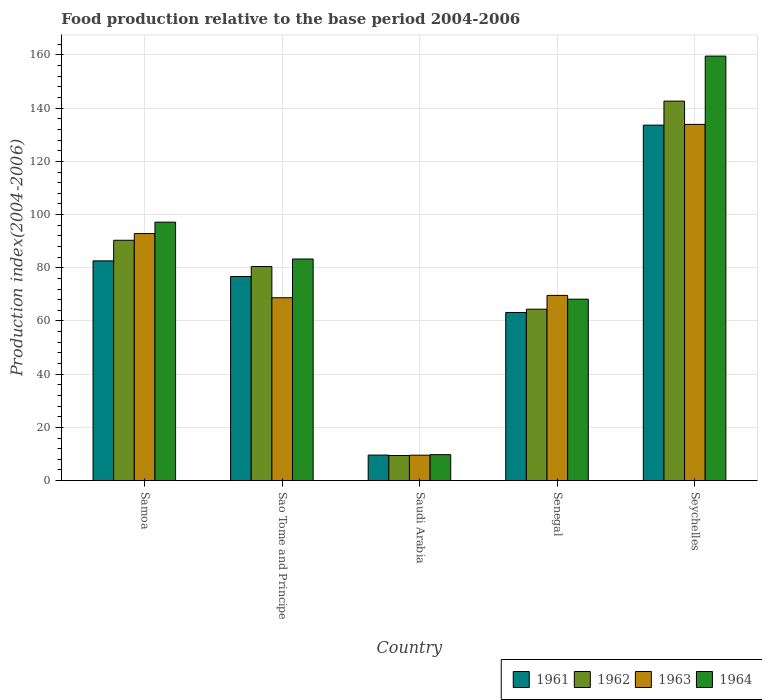How many different coloured bars are there?
Your answer should be very brief. 4. How many groups of bars are there?
Your answer should be compact. 5. How many bars are there on the 2nd tick from the left?
Offer a terse response. 4. How many bars are there on the 5th tick from the right?
Provide a short and direct response. 4. What is the label of the 4th group of bars from the left?
Your answer should be compact. Senegal. In how many cases, is the number of bars for a given country not equal to the number of legend labels?
Keep it short and to the point. 0. What is the food production index in 1964 in Samoa?
Your response must be concise. 97.15. Across all countries, what is the maximum food production index in 1962?
Your answer should be very brief. 142.65. Across all countries, what is the minimum food production index in 1962?
Provide a succinct answer. 9.42. In which country was the food production index in 1961 maximum?
Keep it short and to the point. Seychelles. In which country was the food production index in 1961 minimum?
Ensure brevity in your answer.  Saudi Arabia. What is the total food production index in 1964 in the graph?
Your answer should be very brief. 417.95. What is the difference between the food production index in 1964 in Samoa and that in Seychelles?
Ensure brevity in your answer.  -62.42. What is the difference between the food production index in 1962 in Sao Tome and Principe and the food production index in 1964 in Saudi Arabia?
Ensure brevity in your answer.  70.71. What is the average food production index in 1963 per country?
Ensure brevity in your answer.  74.93. What is the difference between the food production index of/in 1963 and food production index of/in 1964 in Samoa?
Provide a succinct answer. -4.29. What is the ratio of the food production index in 1961 in Samoa to that in Seychelles?
Make the answer very short. 0.62. Is the food production index in 1963 in Sao Tome and Principe less than that in Saudi Arabia?
Provide a short and direct response. No. What is the difference between the highest and the second highest food production index in 1961?
Ensure brevity in your answer.  5.88. What is the difference between the highest and the lowest food production index in 1961?
Keep it short and to the point. 124.04. Is the sum of the food production index in 1961 in Senegal and Seychelles greater than the maximum food production index in 1963 across all countries?
Give a very brief answer. Yes. What does the 3rd bar from the left in Seychelles represents?
Provide a short and direct response. 1963. How many bars are there?
Your answer should be very brief. 20. How many countries are there in the graph?
Provide a short and direct response. 5. What is the difference between two consecutive major ticks on the Y-axis?
Give a very brief answer. 20. Does the graph contain any zero values?
Ensure brevity in your answer.  No. Does the graph contain grids?
Make the answer very short. Yes. Where does the legend appear in the graph?
Give a very brief answer. Bottom right. What is the title of the graph?
Provide a succinct answer. Food production relative to the base period 2004-2006. Does "2014" appear as one of the legend labels in the graph?
Your response must be concise. No. What is the label or title of the X-axis?
Offer a terse response. Country. What is the label or title of the Y-axis?
Ensure brevity in your answer.  Production index(2004-2006). What is the Production index(2004-2006) in 1961 in Samoa?
Provide a short and direct response. 82.6. What is the Production index(2004-2006) in 1962 in Samoa?
Offer a very short reply. 90.34. What is the Production index(2004-2006) in 1963 in Samoa?
Provide a succinct answer. 92.86. What is the Production index(2004-2006) in 1964 in Samoa?
Your answer should be very brief. 97.15. What is the Production index(2004-2006) of 1961 in Sao Tome and Principe?
Give a very brief answer. 76.72. What is the Production index(2004-2006) of 1962 in Sao Tome and Principe?
Keep it short and to the point. 80.46. What is the Production index(2004-2006) in 1963 in Sao Tome and Principe?
Keep it short and to the point. 68.73. What is the Production index(2004-2006) of 1964 in Sao Tome and Principe?
Provide a succinct answer. 83.29. What is the Production index(2004-2006) of 1961 in Saudi Arabia?
Offer a very short reply. 9.58. What is the Production index(2004-2006) of 1962 in Saudi Arabia?
Give a very brief answer. 9.42. What is the Production index(2004-2006) of 1963 in Saudi Arabia?
Offer a terse response. 9.54. What is the Production index(2004-2006) in 1964 in Saudi Arabia?
Your answer should be compact. 9.75. What is the Production index(2004-2006) in 1961 in Senegal?
Ensure brevity in your answer.  63.19. What is the Production index(2004-2006) of 1962 in Senegal?
Your answer should be compact. 64.43. What is the Production index(2004-2006) in 1963 in Senegal?
Ensure brevity in your answer.  69.61. What is the Production index(2004-2006) in 1964 in Senegal?
Offer a very short reply. 68.19. What is the Production index(2004-2006) of 1961 in Seychelles?
Your answer should be very brief. 133.62. What is the Production index(2004-2006) of 1962 in Seychelles?
Offer a terse response. 142.65. What is the Production index(2004-2006) in 1963 in Seychelles?
Ensure brevity in your answer.  133.9. What is the Production index(2004-2006) of 1964 in Seychelles?
Your answer should be compact. 159.57. Across all countries, what is the maximum Production index(2004-2006) in 1961?
Ensure brevity in your answer.  133.62. Across all countries, what is the maximum Production index(2004-2006) of 1962?
Your response must be concise. 142.65. Across all countries, what is the maximum Production index(2004-2006) of 1963?
Give a very brief answer. 133.9. Across all countries, what is the maximum Production index(2004-2006) in 1964?
Your answer should be compact. 159.57. Across all countries, what is the minimum Production index(2004-2006) of 1961?
Give a very brief answer. 9.58. Across all countries, what is the minimum Production index(2004-2006) in 1962?
Ensure brevity in your answer.  9.42. Across all countries, what is the minimum Production index(2004-2006) of 1963?
Make the answer very short. 9.54. Across all countries, what is the minimum Production index(2004-2006) in 1964?
Ensure brevity in your answer.  9.75. What is the total Production index(2004-2006) in 1961 in the graph?
Offer a terse response. 365.71. What is the total Production index(2004-2006) in 1962 in the graph?
Offer a very short reply. 387.3. What is the total Production index(2004-2006) of 1963 in the graph?
Your answer should be compact. 374.64. What is the total Production index(2004-2006) in 1964 in the graph?
Provide a succinct answer. 417.95. What is the difference between the Production index(2004-2006) in 1961 in Samoa and that in Sao Tome and Principe?
Provide a short and direct response. 5.88. What is the difference between the Production index(2004-2006) in 1962 in Samoa and that in Sao Tome and Principe?
Your answer should be compact. 9.88. What is the difference between the Production index(2004-2006) in 1963 in Samoa and that in Sao Tome and Principe?
Your response must be concise. 24.13. What is the difference between the Production index(2004-2006) of 1964 in Samoa and that in Sao Tome and Principe?
Ensure brevity in your answer.  13.86. What is the difference between the Production index(2004-2006) of 1961 in Samoa and that in Saudi Arabia?
Your response must be concise. 73.02. What is the difference between the Production index(2004-2006) of 1962 in Samoa and that in Saudi Arabia?
Offer a very short reply. 80.92. What is the difference between the Production index(2004-2006) in 1963 in Samoa and that in Saudi Arabia?
Make the answer very short. 83.32. What is the difference between the Production index(2004-2006) in 1964 in Samoa and that in Saudi Arabia?
Your response must be concise. 87.4. What is the difference between the Production index(2004-2006) in 1961 in Samoa and that in Senegal?
Offer a very short reply. 19.41. What is the difference between the Production index(2004-2006) in 1962 in Samoa and that in Senegal?
Keep it short and to the point. 25.91. What is the difference between the Production index(2004-2006) of 1963 in Samoa and that in Senegal?
Offer a terse response. 23.25. What is the difference between the Production index(2004-2006) of 1964 in Samoa and that in Senegal?
Make the answer very short. 28.96. What is the difference between the Production index(2004-2006) in 1961 in Samoa and that in Seychelles?
Provide a short and direct response. -51.02. What is the difference between the Production index(2004-2006) in 1962 in Samoa and that in Seychelles?
Provide a short and direct response. -52.31. What is the difference between the Production index(2004-2006) in 1963 in Samoa and that in Seychelles?
Offer a very short reply. -41.04. What is the difference between the Production index(2004-2006) of 1964 in Samoa and that in Seychelles?
Keep it short and to the point. -62.42. What is the difference between the Production index(2004-2006) in 1961 in Sao Tome and Principe and that in Saudi Arabia?
Your answer should be compact. 67.14. What is the difference between the Production index(2004-2006) in 1962 in Sao Tome and Principe and that in Saudi Arabia?
Provide a succinct answer. 71.04. What is the difference between the Production index(2004-2006) of 1963 in Sao Tome and Principe and that in Saudi Arabia?
Make the answer very short. 59.19. What is the difference between the Production index(2004-2006) of 1964 in Sao Tome and Principe and that in Saudi Arabia?
Give a very brief answer. 73.54. What is the difference between the Production index(2004-2006) in 1961 in Sao Tome and Principe and that in Senegal?
Offer a very short reply. 13.53. What is the difference between the Production index(2004-2006) in 1962 in Sao Tome and Principe and that in Senegal?
Your answer should be very brief. 16.03. What is the difference between the Production index(2004-2006) of 1963 in Sao Tome and Principe and that in Senegal?
Keep it short and to the point. -0.88. What is the difference between the Production index(2004-2006) of 1964 in Sao Tome and Principe and that in Senegal?
Provide a short and direct response. 15.1. What is the difference between the Production index(2004-2006) in 1961 in Sao Tome and Principe and that in Seychelles?
Provide a succinct answer. -56.9. What is the difference between the Production index(2004-2006) of 1962 in Sao Tome and Principe and that in Seychelles?
Offer a very short reply. -62.19. What is the difference between the Production index(2004-2006) in 1963 in Sao Tome and Principe and that in Seychelles?
Ensure brevity in your answer.  -65.17. What is the difference between the Production index(2004-2006) in 1964 in Sao Tome and Principe and that in Seychelles?
Your answer should be very brief. -76.28. What is the difference between the Production index(2004-2006) of 1961 in Saudi Arabia and that in Senegal?
Provide a succinct answer. -53.61. What is the difference between the Production index(2004-2006) of 1962 in Saudi Arabia and that in Senegal?
Ensure brevity in your answer.  -55.01. What is the difference between the Production index(2004-2006) of 1963 in Saudi Arabia and that in Senegal?
Offer a very short reply. -60.07. What is the difference between the Production index(2004-2006) of 1964 in Saudi Arabia and that in Senegal?
Provide a succinct answer. -58.44. What is the difference between the Production index(2004-2006) of 1961 in Saudi Arabia and that in Seychelles?
Your answer should be very brief. -124.04. What is the difference between the Production index(2004-2006) of 1962 in Saudi Arabia and that in Seychelles?
Make the answer very short. -133.23. What is the difference between the Production index(2004-2006) in 1963 in Saudi Arabia and that in Seychelles?
Offer a very short reply. -124.36. What is the difference between the Production index(2004-2006) of 1964 in Saudi Arabia and that in Seychelles?
Keep it short and to the point. -149.82. What is the difference between the Production index(2004-2006) of 1961 in Senegal and that in Seychelles?
Make the answer very short. -70.43. What is the difference between the Production index(2004-2006) in 1962 in Senegal and that in Seychelles?
Your response must be concise. -78.22. What is the difference between the Production index(2004-2006) in 1963 in Senegal and that in Seychelles?
Offer a very short reply. -64.29. What is the difference between the Production index(2004-2006) of 1964 in Senegal and that in Seychelles?
Offer a very short reply. -91.38. What is the difference between the Production index(2004-2006) of 1961 in Samoa and the Production index(2004-2006) of 1962 in Sao Tome and Principe?
Your answer should be very brief. 2.14. What is the difference between the Production index(2004-2006) of 1961 in Samoa and the Production index(2004-2006) of 1963 in Sao Tome and Principe?
Offer a very short reply. 13.87. What is the difference between the Production index(2004-2006) of 1961 in Samoa and the Production index(2004-2006) of 1964 in Sao Tome and Principe?
Your response must be concise. -0.69. What is the difference between the Production index(2004-2006) in 1962 in Samoa and the Production index(2004-2006) in 1963 in Sao Tome and Principe?
Provide a short and direct response. 21.61. What is the difference between the Production index(2004-2006) in 1962 in Samoa and the Production index(2004-2006) in 1964 in Sao Tome and Principe?
Provide a short and direct response. 7.05. What is the difference between the Production index(2004-2006) in 1963 in Samoa and the Production index(2004-2006) in 1964 in Sao Tome and Principe?
Make the answer very short. 9.57. What is the difference between the Production index(2004-2006) in 1961 in Samoa and the Production index(2004-2006) in 1962 in Saudi Arabia?
Keep it short and to the point. 73.18. What is the difference between the Production index(2004-2006) of 1961 in Samoa and the Production index(2004-2006) of 1963 in Saudi Arabia?
Your answer should be very brief. 73.06. What is the difference between the Production index(2004-2006) in 1961 in Samoa and the Production index(2004-2006) in 1964 in Saudi Arabia?
Keep it short and to the point. 72.85. What is the difference between the Production index(2004-2006) of 1962 in Samoa and the Production index(2004-2006) of 1963 in Saudi Arabia?
Your answer should be very brief. 80.8. What is the difference between the Production index(2004-2006) in 1962 in Samoa and the Production index(2004-2006) in 1964 in Saudi Arabia?
Provide a succinct answer. 80.59. What is the difference between the Production index(2004-2006) in 1963 in Samoa and the Production index(2004-2006) in 1964 in Saudi Arabia?
Keep it short and to the point. 83.11. What is the difference between the Production index(2004-2006) in 1961 in Samoa and the Production index(2004-2006) in 1962 in Senegal?
Keep it short and to the point. 18.17. What is the difference between the Production index(2004-2006) of 1961 in Samoa and the Production index(2004-2006) of 1963 in Senegal?
Make the answer very short. 12.99. What is the difference between the Production index(2004-2006) of 1961 in Samoa and the Production index(2004-2006) of 1964 in Senegal?
Give a very brief answer. 14.41. What is the difference between the Production index(2004-2006) of 1962 in Samoa and the Production index(2004-2006) of 1963 in Senegal?
Provide a succinct answer. 20.73. What is the difference between the Production index(2004-2006) in 1962 in Samoa and the Production index(2004-2006) in 1964 in Senegal?
Provide a succinct answer. 22.15. What is the difference between the Production index(2004-2006) in 1963 in Samoa and the Production index(2004-2006) in 1964 in Senegal?
Offer a very short reply. 24.67. What is the difference between the Production index(2004-2006) of 1961 in Samoa and the Production index(2004-2006) of 1962 in Seychelles?
Offer a very short reply. -60.05. What is the difference between the Production index(2004-2006) in 1961 in Samoa and the Production index(2004-2006) in 1963 in Seychelles?
Offer a very short reply. -51.3. What is the difference between the Production index(2004-2006) in 1961 in Samoa and the Production index(2004-2006) in 1964 in Seychelles?
Provide a short and direct response. -76.97. What is the difference between the Production index(2004-2006) of 1962 in Samoa and the Production index(2004-2006) of 1963 in Seychelles?
Provide a short and direct response. -43.56. What is the difference between the Production index(2004-2006) in 1962 in Samoa and the Production index(2004-2006) in 1964 in Seychelles?
Your answer should be compact. -69.23. What is the difference between the Production index(2004-2006) in 1963 in Samoa and the Production index(2004-2006) in 1964 in Seychelles?
Ensure brevity in your answer.  -66.71. What is the difference between the Production index(2004-2006) in 1961 in Sao Tome and Principe and the Production index(2004-2006) in 1962 in Saudi Arabia?
Offer a terse response. 67.3. What is the difference between the Production index(2004-2006) in 1961 in Sao Tome and Principe and the Production index(2004-2006) in 1963 in Saudi Arabia?
Your response must be concise. 67.18. What is the difference between the Production index(2004-2006) of 1961 in Sao Tome and Principe and the Production index(2004-2006) of 1964 in Saudi Arabia?
Make the answer very short. 66.97. What is the difference between the Production index(2004-2006) of 1962 in Sao Tome and Principe and the Production index(2004-2006) of 1963 in Saudi Arabia?
Offer a very short reply. 70.92. What is the difference between the Production index(2004-2006) of 1962 in Sao Tome and Principe and the Production index(2004-2006) of 1964 in Saudi Arabia?
Make the answer very short. 70.71. What is the difference between the Production index(2004-2006) in 1963 in Sao Tome and Principe and the Production index(2004-2006) in 1964 in Saudi Arabia?
Provide a succinct answer. 58.98. What is the difference between the Production index(2004-2006) in 1961 in Sao Tome and Principe and the Production index(2004-2006) in 1962 in Senegal?
Your response must be concise. 12.29. What is the difference between the Production index(2004-2006) in 1961 in Sao Tome and Principe and the Production index(2004-2006) in 1963 in Senegal?
Your answer should be very brief. 7.11. What is the difference between the Production index(2004-2006) in 1961 in Sao Tome and Principe and the Production index(2004-2006) in 1964 in Senegal?
Offer a terse response. 8.53. What is the difference between the Production index(2004-2006) in 1962 in Sao Tome and Principe and the Production index(2004-2006) in 1963 in Senegal?
Your response must be concise. 10.85. What is the difference between the Production index(2004-2006) in 1962 in Sao Tome and Principe and the Production index(2004-2006) in 1964 in Senegal?
Provide a short and direct response. 12.27. What is the difference between the Production index(2004-2006) in 1963 in Sao Tome and Principe and the Production index(2004-2006) in 1964 in Senegal?
Offer a very short reply. 0.54. What is the difference between the Production index(2004-2006) in 1961 in Sao Tome and Principe and the Production index(2004-2006) in 1962 in Seychelles?
Offer a very short reply. -65.93. What is the difference between the Production index(2004-2006) of 1961 in Sao Tome and Principe and the Production index(2004-2006) of 1963 in Seychelles?
Provide a succinct answer. -57.18. What is the difference between the Production index(2004-2006) of 1961 in Sao Tome and Principe and the Production index(2004-2006) of 1964 in Seychelles?
Give a very brief answer. -82.85. What is the difference between the Production index(2004-2006) of 1962 in Sao Tome and Principe and the Production index(2004-2006) of 1963 in Seychelles?
Offer a terse response. -53.44. What is the difference between the Production index(2004-2006) in 1962 in Sao Tome and Principe and the Production index(2004-2006) in 1964 in Seychelles?
Provide a succinct answer. -79.11. What is the difference between the Production index(2004-2006) in 1963 in Sao Tome and Principe and the Production index(2004-2006) in 1964 in Seychelles?
Your answer should be compact. -90.84. What is the difference between the Production index(2004-2006) in 1961 in Saudi Arabia and the Production index(2004-2006) in 1962 in Senegal?
Your answer should be compact. -54.85. What is the difference between the Production index(2004-2006) of 1961 in Saudi Arabia and the Production index(2004-2006) of 1963 in Senegal?
Keep it short and to the point. -60.03. What is the difference between the Production index(2004-2006) in 1961 in Saudi Arabia and the Production index(2004-2006) in 1964 in Senegal?
Your answer should be very brief. -58.61. What is the difference between the Production index(2004-2006) in 1962 in Saudi Arabia and the Production index(2004-2006) in 1963 in Senegal?
Your answer should be compact. -60.19. What is the difference between the Production index(2004-2006) of 1962 in Saudi Arabia and the Production index(2004-2006) of 1964 in Senegal?
Make the answer very short. -58.77. What is the difference between the Production index(2004-2006) of 1963 in Saudi Arabia and the Production index(2004-2006) of 1964 in Senegal?
Ensure brevity in your answer.  -58.65. What is the difference between the Production index(2004-2006) in 1961 in Saudi Arabia and the Production index(2004-2006) in 1962 in Seychelles?
Your answer should be compact. -133.07. What is the difference between the Production index(2004-2006) in 1961 in Saudi Arabia and the Production index(2004-2006) in 1963 in Seychelles?
Your answer should be compact. -124.32. What is the difference between the Production index(2004-2006) in 1961 in Saudi Arabia and the Production index(2004-2006) in 1964 in Seychelles?
Provide a succinct answer. -149.99. What is the difference between the Production index(2004-2006) of 1962 in Saudi Arabia and the Production index(2004-2006) of 1963 in Seychelles?
Give a very brief answer. -124.48. What is the difference between the Production index(2004-2006) of 1962 in Saudi Arabia and the Production index(2004-2006) of 1964 in Seychelles?
Keep it short and to the point. -150.15. What is the difference between the Production index(2004-2006) of 1963 in Saudi Arabia and the Production index(2004-2006) of 1964 in Seychelles?
Keep it short and to the point. -150.03. What is the difference between the Production index(2004-2006) in 1961 in Senegal and the Production index(2004-2006) in 1962 in Seychelles?
Make the answer very short. -79.46. What is the difference between the Production index(2004-2006) in 1961 in Senegal and the Production index(2004-2006) in 1963 in Seychelles?
Keep it short and to the point. -70.71. What is the difference between the Production index(2004-2006) in 1961 in Senegal and the Production index(2004-2006) in 1964 in Seychelles?
Your answer should be very brief. -96.38. What is the difference between the Production index(2004-2006) in 1962 in Senegal and the Production index(2004-2006) in 1963 in Seychelles?
Keep it short and to the point. -69.47. What is the difference between the Production index(2004-2006) in 1962 in Senegal and the Production index(2004-2006) in 1964 in Seychelles?
Give a very brief answer. -95.14. What is the difference between the Production index(2004-2006) in 1963 in Senegal and the Production index(2004-2006) in 1964 in Seychelles?
Make the answer very short. -89.96. What is the average Production index(2004-2006) in 1961 per country?
Provide a short and direct response. 73.14. What is the average Production index(2004-2006) of 1962 per country?
Provide a succinct answer. 77.46. What is the average Production index(2004-2006) in 1963 per country?
Provide a succinct answer. 74.93. What is the average Production index(2004-2006) in 1964 per country?
Offer a very short reply. 83.59. What is the difference between the Production index(2004-2006) in 1961 and Production index(2004-2006) in 1962 in Samoa?
Your answer should be very brief. -7.74. What is the difference between the Production index(2004-2006) in 1961 and Production index(2004-2006) in 1963 in Samoa?
Provide a succinct answer. -10.26. What is the difference between the Production index(2004-2006) of 1961 and Production index(2004-2006) of 1964 in Samoa?
Ensure brevity in your answer.  -14.55. What is the difference between the Production index(2004-2006) of 1962 and Production index(2004-2006) of 1963 in Samoa?
Ensure brevity in your answer.  -2.52. What is the difference between the Production index(2004-2006) in 1962 and Production index(2004-2006) in 1964 in Samoa?
Your answer should be very brief. -6.81. What is the difference between the Production index(2004-2006) of 1963 and Production index(2004-2006) of 1964 in Samoa?
Offer a terse response. -4.29. What is the difference between the Production index(2004-2006) of 1961 and Production index(2004-2006) of 1962 in Sao Tome and Principe?
Keep it short and to the point. -3.74. What is the difference between the Production index(2004-2006) in 1961 and Production index(2004-2006) in 1963 in Sao Tome and Principe?
Your answer should be compact. 7.99. What is the difference between the Production index(2004-2006) in 1961 and Production index(2004-2006) in 1964 in Sao Tome and Principe?
Make the answer very short. -6.57. What is the difference between the Production index(2004-2006) of 1962 and Production index(2004-2006) of 1963 in Sao Tome and Principe?
Your answer should be very brief. 11.73. What is the difference between the Production index(2004-2006) in 1962 and Production index(2004-2006) in 1964 in Sao Tome and Principe?
Your response must be concise. -2.83. What is the difference between the Production index(2004-2006) in 1963 and Production index(2004-2006) in 1964 in Sao Tome and Principe?
Give a very brief answer. -14.56. What is the difference between the Production index(2004-2006) of 1961 and Production index(2004-2006) of 1962 in Saudi Arabia?
Make the answer very short. 0.16. What is the difference between the Production index(2004-2006) in 1961 and Production index(2004-2006) in 1963 in Saudi Arabia?
Your response must be concise. 0.04. What is the difference between the Production index(2004-2006) in 1961 and Production index(2004-2006) in 1964 in Saudi Arabia?
Provide a short and direct response. -0.17. What is the difference between the Production index(2004-2006) in 1962 and Production index(2004-2006) in 1963 in Saudi Arabia?
Provide a succinct answer. -0.12. What is the difference between the Production index(2004-2006) in 1962 and Production index(2004-2006) in 1964 in Saudi Arabia?
Your answer should be very brief. -0.33. What is the difference between the Production index(2004-2006) of 1963 and Production index(2004-2006) of 1964 in Saudi Arabia?
Offer a very short reply. -0.21. What is the difference between the Production index(2004-2006) of 1961 and Production index(2004-2006) of 1962 in Senegal?
Your answer should be compact. -1.24. What is the difference between the Production index(2004-2006) in 1961 and Production index(2004-2006) in 1963 in Senegal?
Your answer should be compact. -6.42. What is the difference between the Production index(2004-2006) of 1962 and Production index(2004-2006) of 1963 in Senegal?
Provide a succinct answer. -5.18. What is the difference between the Production index(2004-2006) of 1962 and Production index(2004-2006) of 1964 in Senegal?
Offer a very short reply. -3.76. What is the difference between the Production index(2004-2006) in 1963 and Production index(2004-2006) in 1964 in Senegal?
Offer a very short reply. 1.42. What is the difference between the Production index(2004-2006) in 1961 and Production index(2004-2006) in 1962 in Seychelles?
Your response must be concise. -9.03. What is the difference between the Production index(2004-2006) in 1961 and Production index(2004-2006) in 1963 in Seychelles?
Your answer should be very brief. -0.28. What is the difference between the Production index(2004-2006) in 1961 and Production index(2004-2006) in 1964 in Seychelles?
Offer a terse response. -25.95. What is the difference between the Production index(2004-2006) in 1962 and Production index(2004-2006) in 1963 in Seychelles?
Offer a very short reply. 8.75. What is the difference between the Production index(2004-2006) in 1962 and Production index(2004-2006) in 1964 in Seychelles?
Provide a short and direct response. -16.92. What is the difference between the Production index(2004-2006) in 1963 and Production index(2004-2006) in 1964 in Seychelles?
Ensure brevity in your answer.  -25.67. What is the ratio of the Production index(2004-2006) in 1961 in Samoa to that in Sao Tome and Principe?
Give a very brief answer. 1.08. What is the ratio of the Production index(2004-2006) in 1962 in Samoa to that in Sao Tome and Principe?
Provide a short and direct response. 1.12. What is the ratio of the Production index(2004-2006) of 1963 in Samoa to that in Sao Tome and Principe?
Offer a very short reply. 1.35. What is the ratio of the Production index(2004-2006) in 1964 in Samoa to that in Sao Tome and Principe?
Keep it short and to the point. 1.17. What is the ratio of the Production index(2004-2006) of 1961 in Samoa to that in Saudi Arabia?
Provide a short and direct response. 8.62. What is the ratio of the Production index(2004-2006) of 1962 in Samoa to that in Saudi Arabia?
Make the answer very short. 9.59. What is the ratio of the Production index(2004-2006) of 1963 in Samoa to that in Saudi Arabia?
Keep it short and to the point. 9.73. What is the ratio of the Production index(2004-2006) of 1964 in Samoa to that in Saudi Arabia?
Your answer should be very brief. 9.96. What is the ratio of the Production index(2004-2006) of 1961 in Samoa to that in Senegal?
Offer a very short reply. 1.31. What is the ratio of the Production index(2004-2006) in 1962 in Samoa to that in Senegal?
Your answer should be compact. 1.4. What is the ratio of the Production index(2004-2006) in 1963 in Samoa to that in Senegal?
Keep it short and to the point. 1.33. What is the ratio of the Production index(2004-2006) in 1964 in Samoa to that in Senegal?
Ensure brevity in your answer.  1.42. What is the ratio of the Production index(2004-2006) in 1961 in Samoa to that in Seychelles?
Your answer should be very brief. 0.62. What is the ratio of the Production index(2004-2006) of 1962 in Samoa to that in Seychelles?
Provide a short and direct response. 0.63. What is the ratio of the Production index(2004-2006) in 1963 in Samoa to that in Seychelles?
Give a very brief answer. 0.69. What is the ratio of the Production index(2004-2006) in 1964 in Samoa to that in Seychelles?
Keep it short and to the point. 0.61. What is the ratio of the Production index(2004-2006) of 1961 in Sao Tome and Principe to that in Saudi Arabia?
Give a very brief answer. 8.01. What is the ratio of the Production index(2004-2006) in 1962 in Sao Tome and Principe to that in Saudi Arabia?
Give a very brief answer. 8.54. What is the ratio of the Production index(2004-2006) in 1963 in Sao Tome and Principe to that in Saudi Arabia?
Keep it short and to the point. 7.2. What is the ratio of the Production index(2004-2006) of 1964 in Sao Tome and Principe to that in Saudi Arabia?
Offer a very short reply. 8.54. What is the ratio of the Production index(2004-2006) in 1961 in Sao Tome and Principe to that in Senegal?
Give a very brief answer. 1.21. What is the ratio of the Production index(2004-2006) in 1962 in Sao Tome and Principe to that in Senegal?
Your answer should be very brief. 1.25. What is the ratio of the Production index(2004-2006) in 1963 in Sao Tome and Principe to that in Senegal?
Provide a short and direct response. 0.99. What is the ratio of the Production index(2004-2006) in 1964 in Sao Tome and Principe to that in Senegal?
Your response must be concise. 1.22. What is the ratio of the Production index(2004-2006) of 1961 in Sao Tome and Principe to that in Seychelles?
Keep it short and to the point. 0.57. What is the ratio of the Production index(2004-2006) in 1962 in Sao Tome and Principe to that in Seychelles?
Offer a very short reply. 0.56. What is the ratio of the Production index(2004-2006) in 1963 in Sao Tome and Principe to that in Seychelles?
Give a very brief answer. 0.51. What is the ratio of the Production index(2004-2006) in 1964 in Sao Tome and Principe to that in Seychelles?
Offer a terse response. 0.52. What is the ratio of the Production index(2004-2006) in 1961 in Saudi Arabia to that in Senegal?
Your answer should be compact. 0.15. What is the ratio of the Production index(2004-2006) of 1962 in Saudi Arabia to that in Senegal?
Your answer should be very brief. 0.15. What is the ratio of the Production index(2004-2006) of 1963 in Saudi Arabia to that in Senegal?
Ensure brevity in your answer.  0.14. What is the ratio of the Production index(2004-2006) in 1964 in Saudi Arabia to that in Senegal?
Offer a very short reply. 0.14. What is the ratio of the Production index(2004-2006) in 1961 in Saudi Arabia to that in Seychelles?
Provide a short and direct response. 0.07. What is the ratio of the Production index(2004-2006) of 1962 in Saudi Arabia to that in Seychelles?
Make the answer very short. 0.07. What is the ratio of the Production index(2004-2006) of 1963 in Saudi Arabia to that in Seychelles?
Provide a succinct answer. 0.07. What is the ratio of the Production index(2004-2006) in 1964 in Saudi Arabia to that in Seychelles?
Ensure brevity in your answer.  0.06. What is the ratio of the Production index(2004-2006) of 1961 in Senegal to that in Seychelles?
Your response must be concise. 0.47. What is the ratio of the Production index(2004-2006) in 1962 in Senegal to that in Seychelles?
Ensure brevity in your answer.  0.45. What is the ratio of the Production index(2004-2006) of 1963 in Senegal to that in Seychelles?
Your response must be concise. 0.52. What is the ratio of the Production index(2004-2006) of 1964 in Senegal to that in Seychelles?
Provide a short and direct response. 0.43. What is the difference between the highest and the second highest Production index(2004-2006) in 1961?
Make the answer very short. 51.02. What is the difference between the highest and the second highest Production index(2004-2006) of 1962?
Give a very brief answer. 52.31. What is the difference between the highest and the second highest Production index(2004-2006) of 1963?
Make the answer very short. 41.04. What is the difference between the highest and the second highest Production index(2004-2006) of 1964?
Your response must be concise. 62.42. What is the difference between the highest and the lowest Production index(2004-2006) in 1961?
Give a very brief answer. 124.04. What is the difference between the highest and the lowest Production index(2004-2006) of 1962?
Make the answer very short. 133.23. What is the difference between the highest and the lowest Production index(2004-2006) of 1963?
Offer a very short reply. 124.36. What is the difference between the highest and the lowest Production index(2004-2006) of 1964?
Make the answer very short. 149.82. 